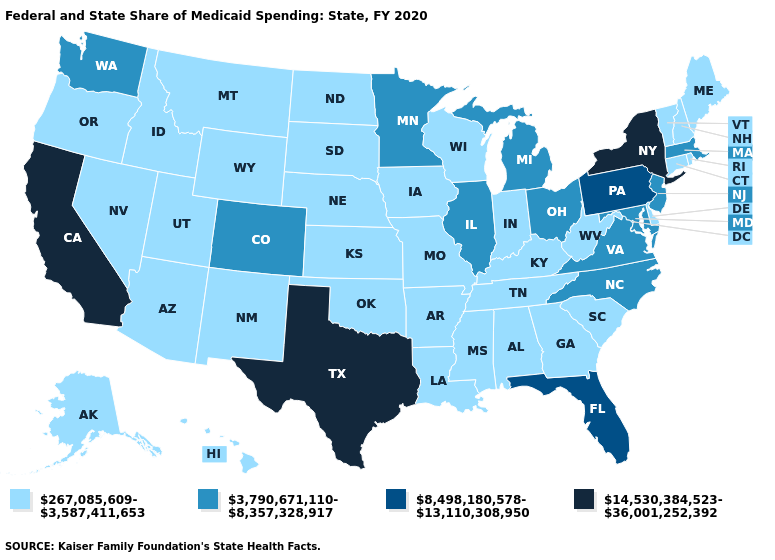Name the states that have a value in the range 267,085,609-3,587,411,653?
Keep it brief. Alabama, Alaska, Arizona, Arkansas, Connecticut, Delaware, Georgia, Hawaii, Idaho, Indiana, Iowa, Kansas, Kentucky, Louisiana, Maine, Mississippi, Missouri, Montana, Nebraska, Nevada, New Hampshire, New Mexico, North Dakota, Oklahoma, Oregon, Rhode Island, South Carolina, South Dakota, Tennessee, Utah, Vermont, West Virginia, Wisconsin, Wyoming. Which states hav the highest value in the West?
Concise answer only. California. Does Michigan have the lowest value in the USA?
Be succinct. No. Name the states that have a value in the range 14,530,384,523-36,001,252,392?
Be succinct. California, New York, Texas. Name the states that have a value in the range 267,085,609-3,587,411,653?
Be succinct. Alabama, Alaska, Arizona, Arkansas, Connecticut, Delaware, Georgia, Hawaii, Idaho, Indiana, Iowa, Kansas, Kentucky, Louisiana, Maine, Mississippi, Missouri, Montana, Nebraska, Nevada, New Hampshire, New Mexico, North Dakota, Oklahoma, Oregon, Rhode Island, South Carolina, South Dakota, Tennessee, Utah, Vermont, West Virginia, Wisconsin, Wyoming. What is the value of Hawaii?
Be succinct. 267,085,609-3,587,411,653. What is the value of Wisconsin?
Give a very brief answer. 267,085,609-3,587,411,653. What is the value of Maryland?
Give a very brief answer. 3,790,671,110-8,357,328,917. Name the states that have a value in the range 8,498,180,578-13,110,308,950?
Keep it brief. Florida, Pennsylvania. Among the states that border New York , does Pennsylvania have the highest value?
Give a very brief answer. Yes. Does Idaho have a higher value than Virginia?
Concise answer only. No. Name the states that have a value in the range 8,498,180,578-13,110,308,950?
Write a very short answer. Florida, Pennsylvania. Name the states that have a value in the range 8,498,180,578-13,110,308,950?
Short answer required. Florida, Pennsylvania. Does New York have the lowest value in the Northeast?
Give a very brief answer. No. 